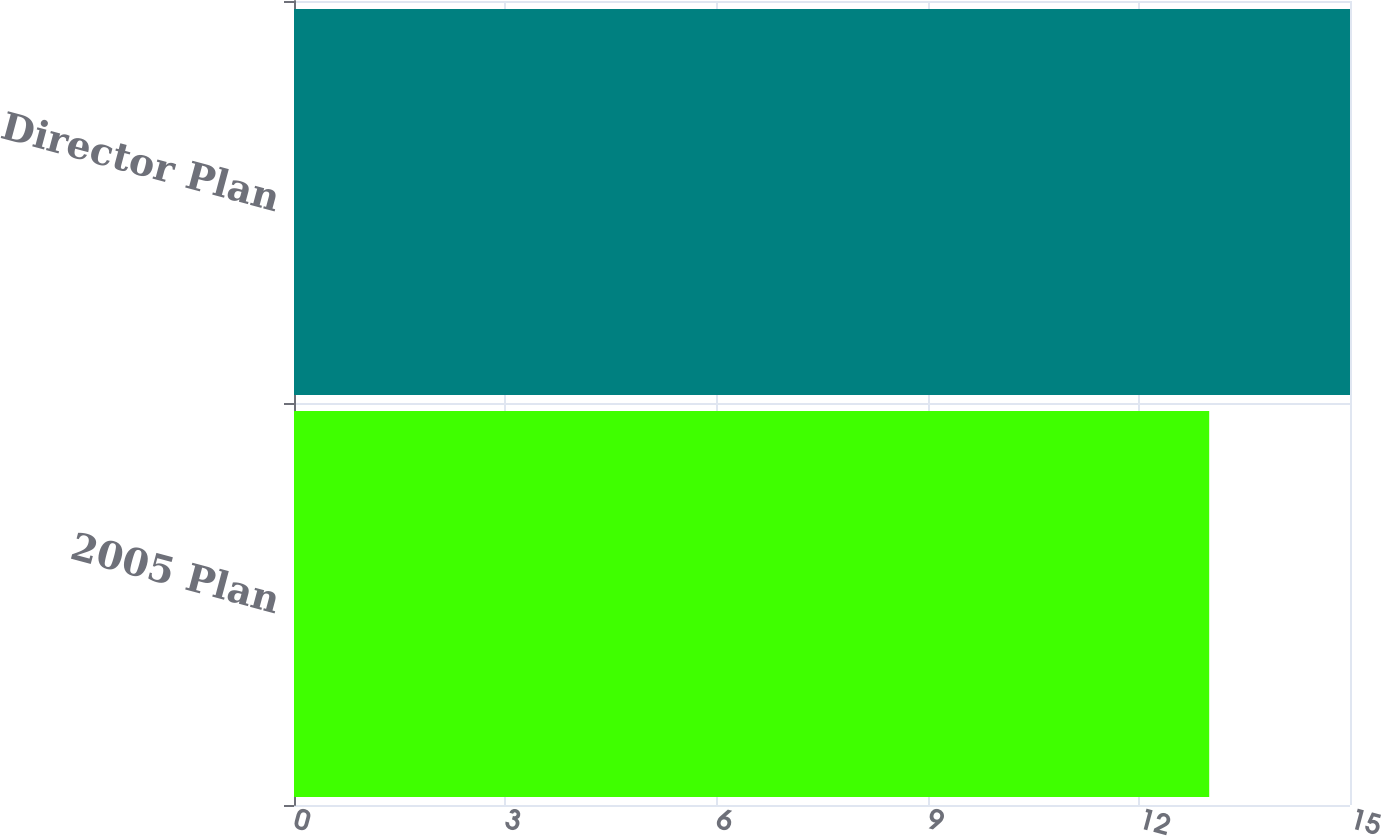Convert chart. <chart><loc_0><loc_0><loc_500><loc_500><bar_chart><fcel>2005 Plan<fcel>Director Plan<nl><fcel>13<fcel>15<nl></chart> 